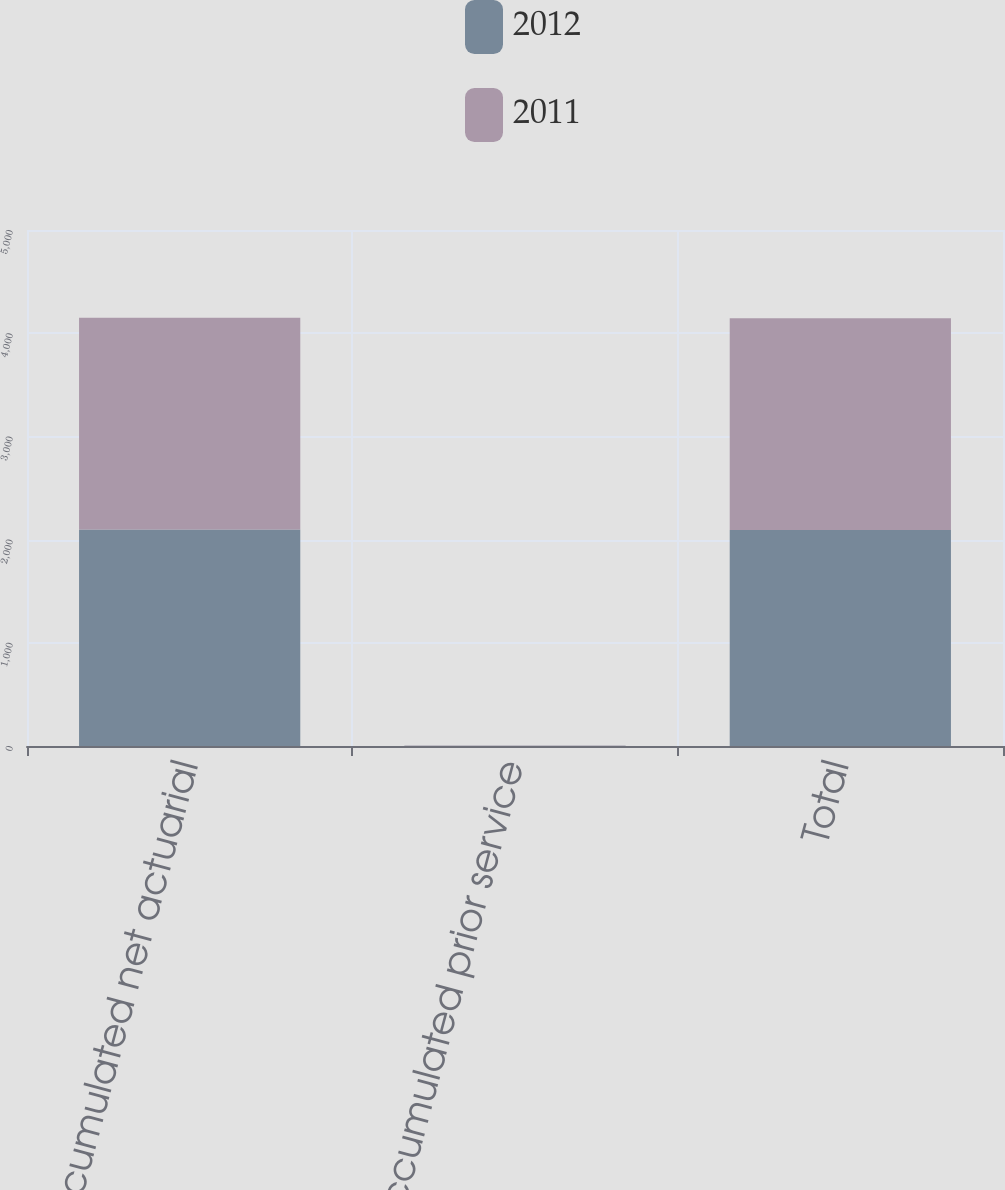Convert chart to OTSL. <chart><loc_0><loc_0><loc_500><loc_500><stacked_bar_chart><ecel><fcel>Accumulated net actuarial<fcel>Accumulated prior service<fcel>Total<nl><fcel>2012<fcel>2097<fcel>3<fcel>2094<nl><fcel>2011<fcel>2052<fcel>2<fcel>2050<nl></chart> 